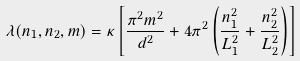Convert formula to latex. <formula><loc_0><loc_0><loc_500><loc_500>\lambda ( n _ { 1 } , n _ { 2 } , m ) = \kappa \left [ \frac { \pi ^ { 2 } m ^ { 2 } } { d ^ { 2 } } + 4 \pi ^ { 2 } \left ( \frac { n _ { 1 } ^ { 2 } } { L _ { 1 } ^ { 2 } } + \frac { n _ { 2 } ^ { 2 } } { L _ { 2 } ^ { 2 } } \right ) \right ]</formula> 